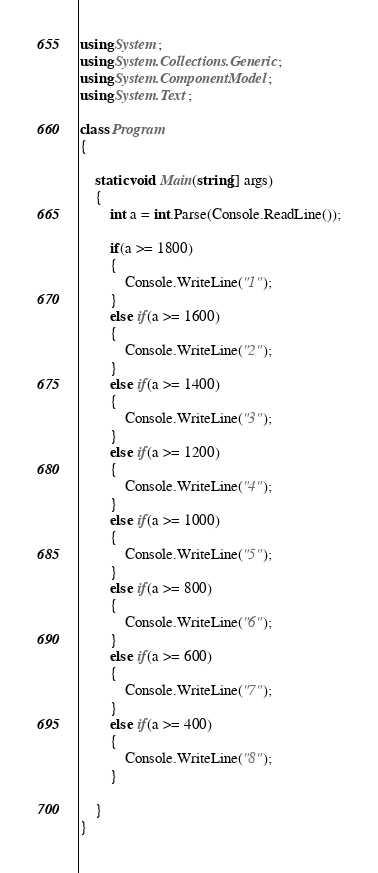<code> <loc_0><loc_0><loc_500><loc_500><_C#_>using System;
using System.Collections.Generic;
using System.ComponentModel;
using System.Text;

class Program
{

	static void Main(string[] args)
	{
		int a = int.Parse(Console.ReadLine());

		if(a >= 1800)
        {
			Console.WriteLine("1");
		}
		else if(a >= 1600)
        {
			Console.WriteLine("2");
		}
		else if(a >= 1400)
        {
			Console.WriteLine("3");
		}
		else if(a >= 1200)
        {
			Console.WriteLine("4");
		}
		else if(a >= 1000)
        {
			Console.WriteLine("5");
		}
		else if(a >= 800)
        {
			Console.WriteLine("6");
		}
		else if(a >= 600)
        {
			Console.WriteLine("7");
		}
		else if(a >= 400)
        {
			Console.WriteLine("8");
		}
		
	}
}</code> 